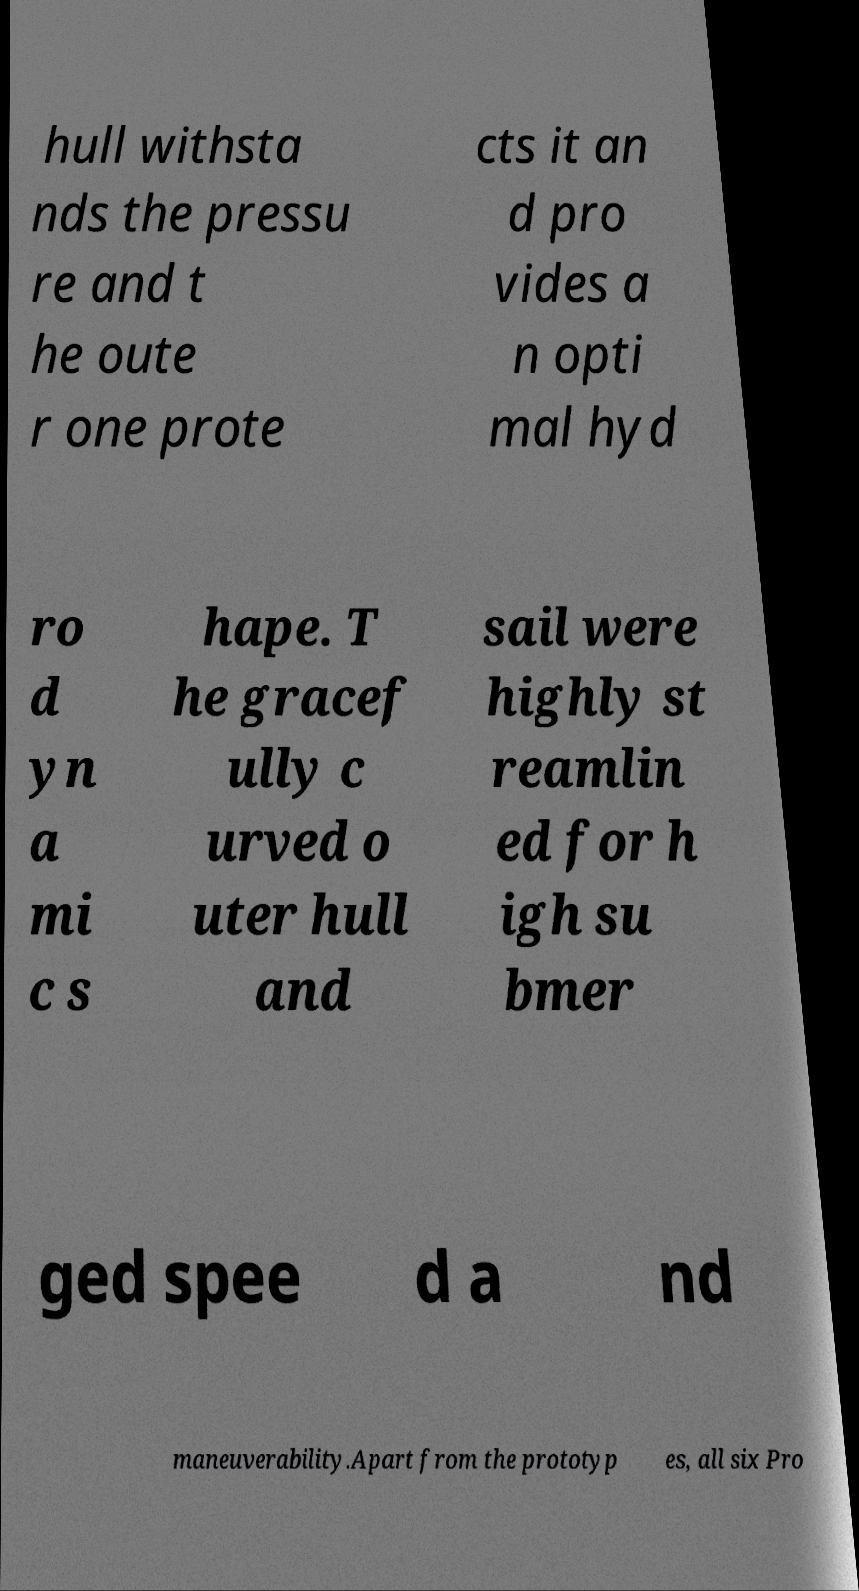I need the written content from this picture converted into text. Can you do that? hull withsta nds the pressu re and t he oute r one prote cts it an d pro vides a n opti mal hyd ro d yn a mi c s hape. T he gracef ully c urved o uter hull and sail were highly st reamlin ed for h igh su bmer ged spee d a nd maneuverability.Apart from the prototyp es, all six Pro 